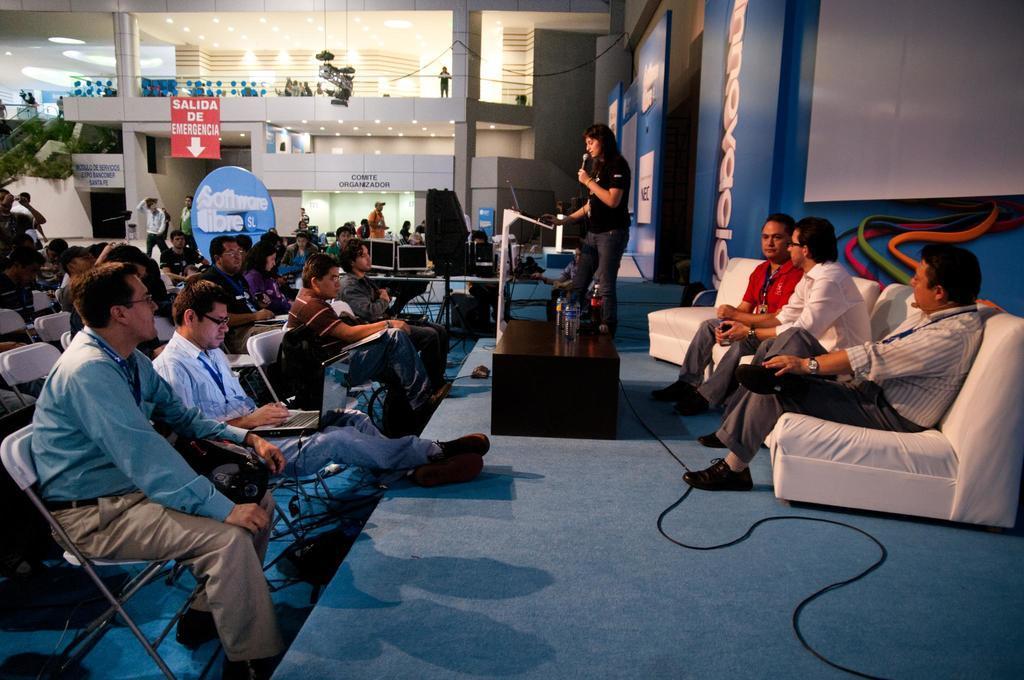Could you give a brief overview of what you see in this image? On the left side of the image we can see a few people are sitting and a few people are holding some objects. In the center of the image, we can see one stage. On the stage, we can see one person is standing and three persons are sitting. Among them, we can see two persons are holding some objects. In front of them, we can see one one stand, microphone, table, water bottles and a few other objects. In the background there is a wall, pillars, banners, lights, few people are standing and a few other objects. On the banners, we can see some text. 